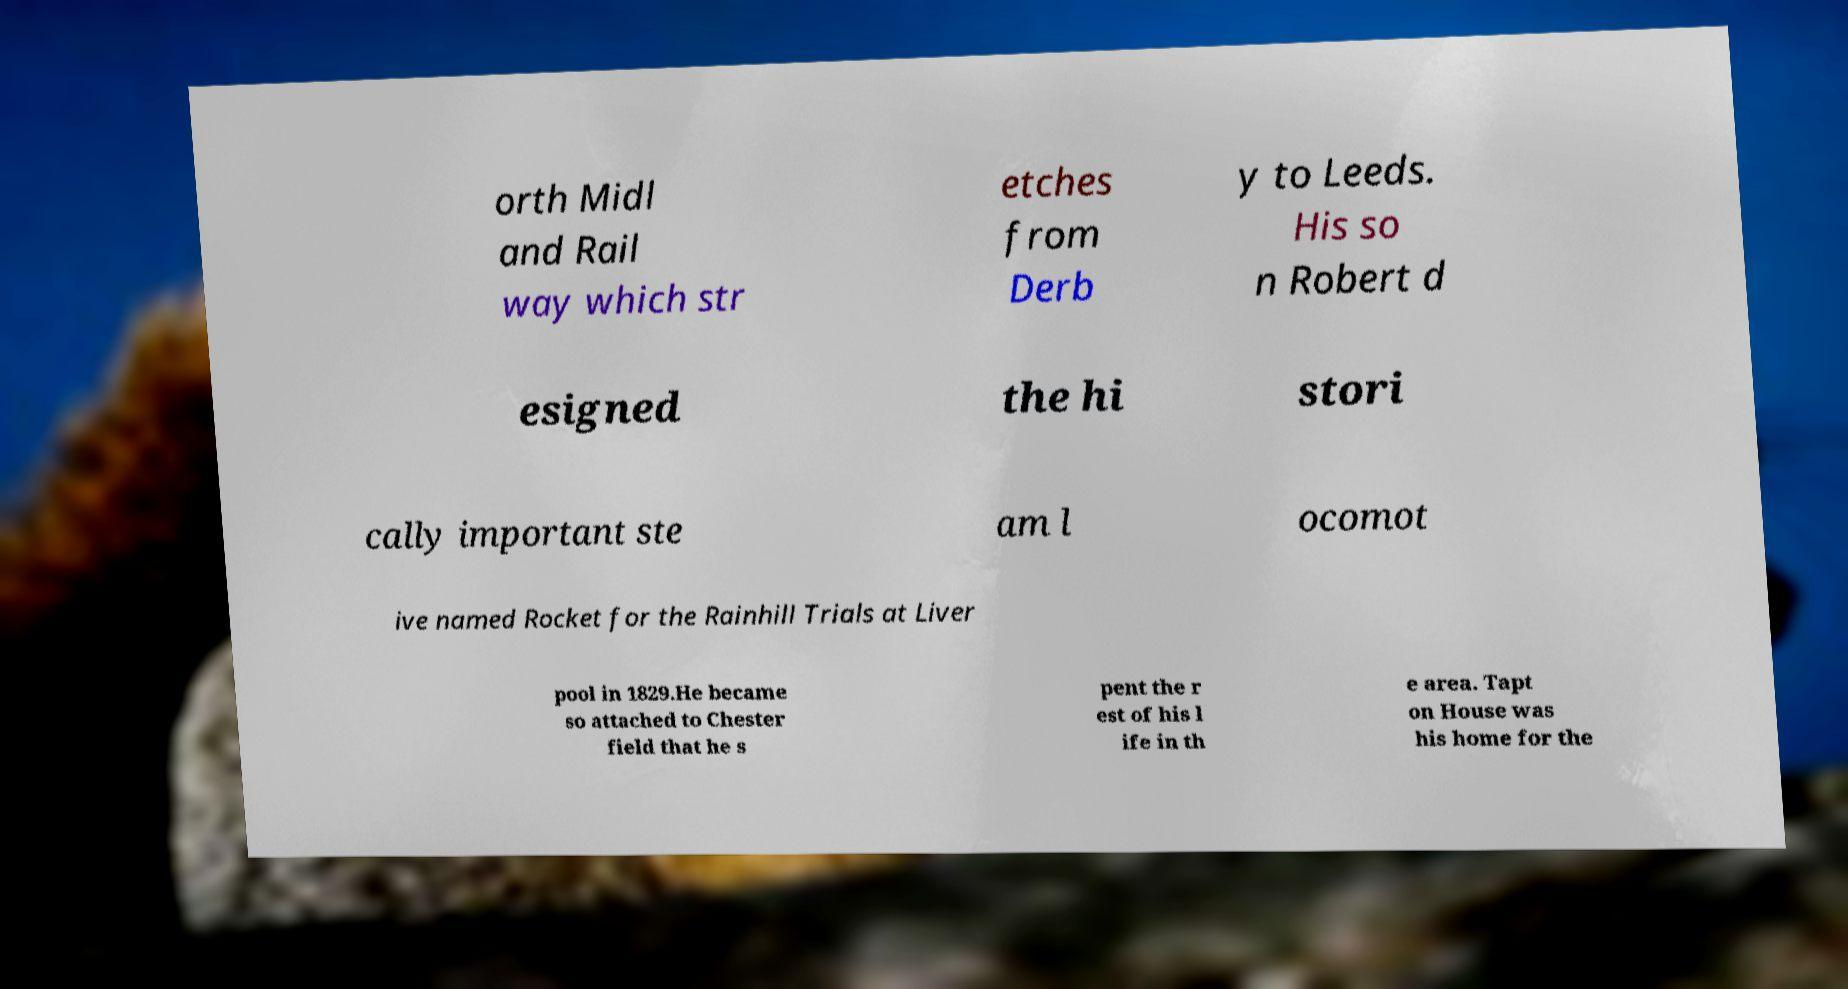Could you extract and type out the text from this image? orth Midl and Rail way which str etches from Derb y to Leeds. His so n Robert d esigned the hi stori cally important ste am l ocomot ive named Rocket for the Rainhill Trials at Liver pool in 1829.He became so attached to Chester field that he s pent the r est of his l ife in th e area. Tapt on House was his home for the 